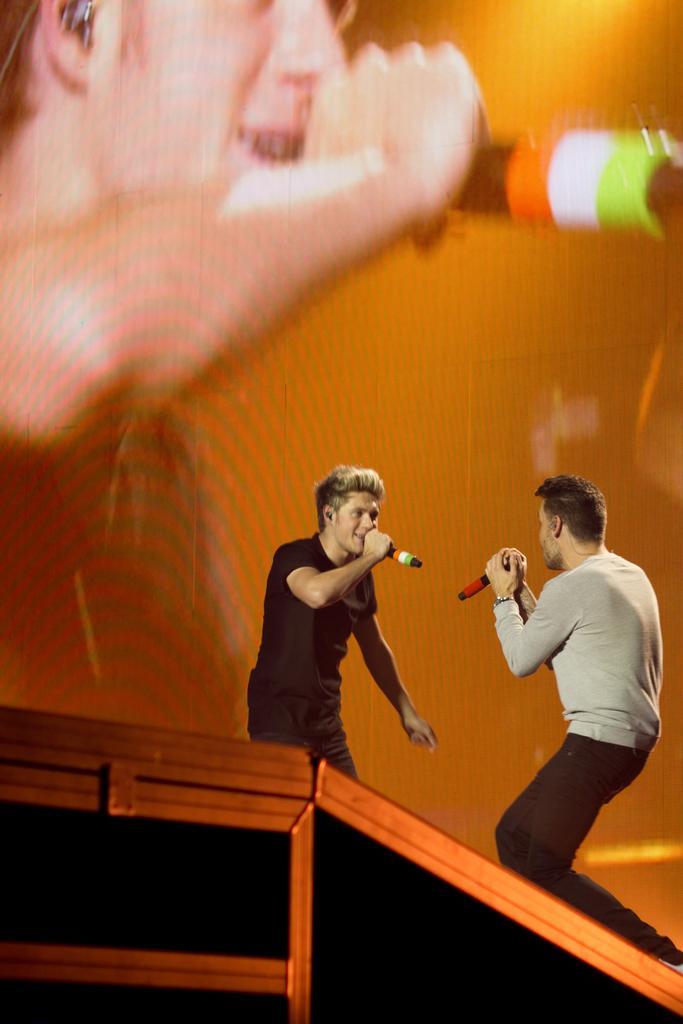Describe this image in one or two sentences. At the bottom of the image there is a box. Behind the box there are two men standing and holding mics in their hands. Behind them there is a screen. On the screen there is a man holding a mic. 